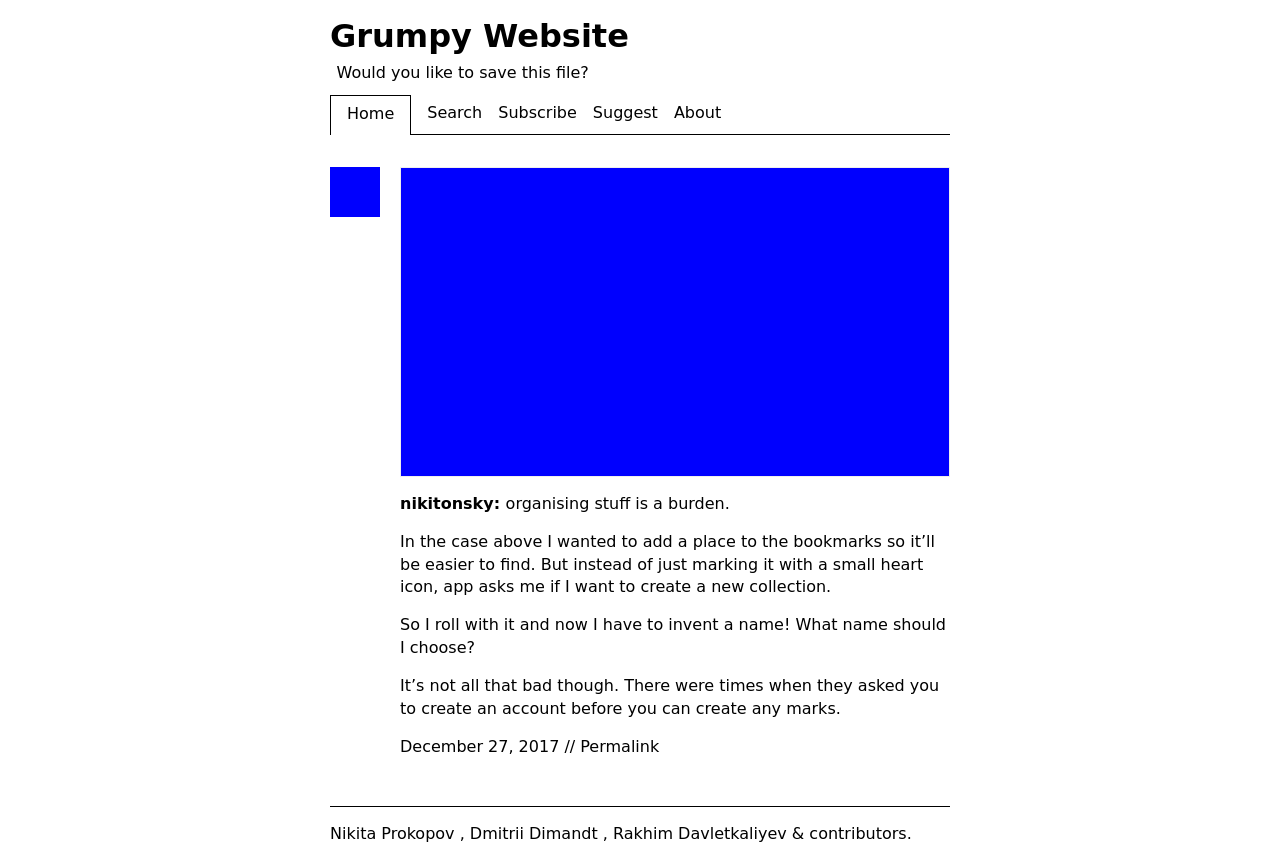What are the design considerations taken for the layout of this website? The design layout of the website in the image prioritizes readability and simplicity. A monochromatic color scheme is used, with ample white space around text blocks for a clean, uncluttered look. Navigation is made simple with a straightforward menu bar, and consistency is maintained throughout the page to provide a seamless user experience. 